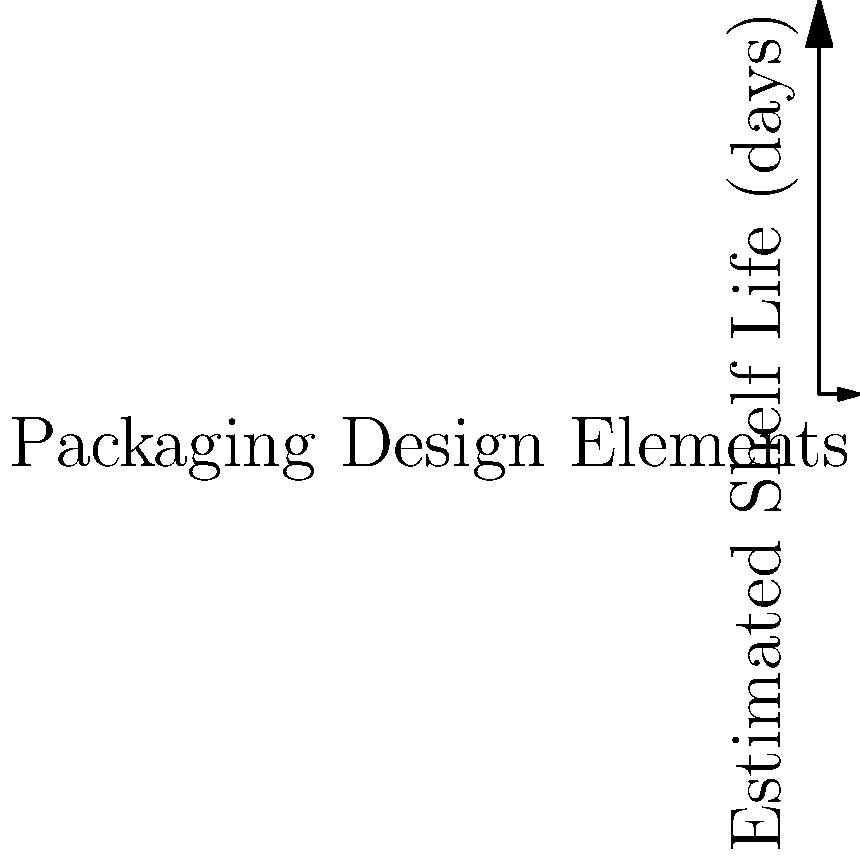As an entrepreneur balancing creativity and tradition in artisanal products, you're analyzing the relationship between packaging design elements and estimated shelf life. Given the trend shown in the graph, what would be the approximate shelf life (in days) for a product with 5 modern design elements? To solve this problem, we'll follow these steps:

1. Observe the graph: It shows a positive linear relationship between the number of packaging design elements and the estimated shelf life.

2. Identify the trend line: The blue line represents the general trend of the data.

3. Understand the axes:
   - X-axis: Number of packaging design elements (0-10)
   - Y-axis: Estimated shelf life in days (0-100)

4. Locate the point of interest: We need to find the shelf life for a product with 5 design elements.

5. Use the trend line to estimate:
   - Find where x = 5 on the x-axis
   - Move up to where this intersects the trend line
   - Read the corresponding y-value

6. Estimate the y-value:
   - It appears to be between 50 and 60 days

7. For more precision, we can use the line equation:
   y = mx + b
   where m ≈ 15.833 (slope) and b ≈ 1.667 (y-intercept)

8. Calculate:
   y = 15.833 * 5 + 1.667 ≈ 80.832

Therefore, the estimated shelf life for a product with 5 modern design elements is approximately 81 days.
Answer: 81 days 